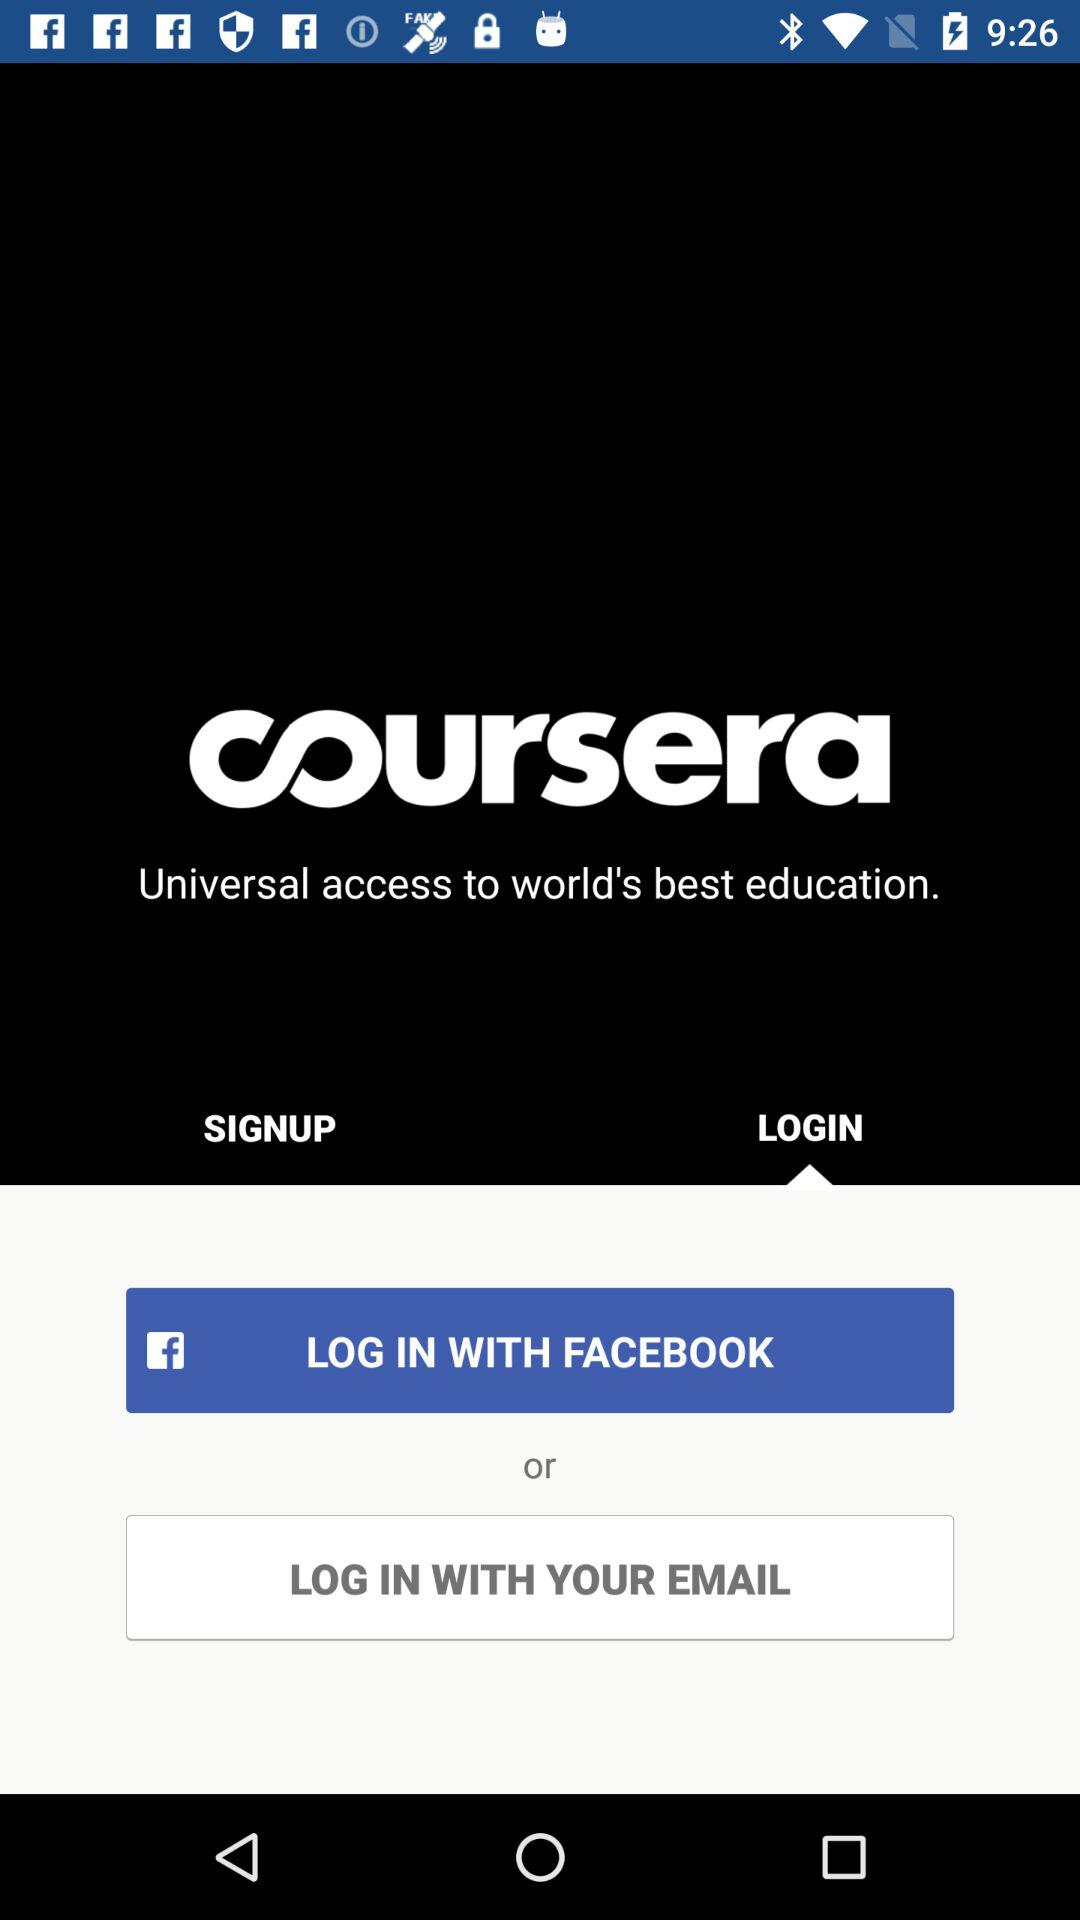Through which account can we log in? You can log in through "FACEBOOK" and "EMAIL" accounts. 